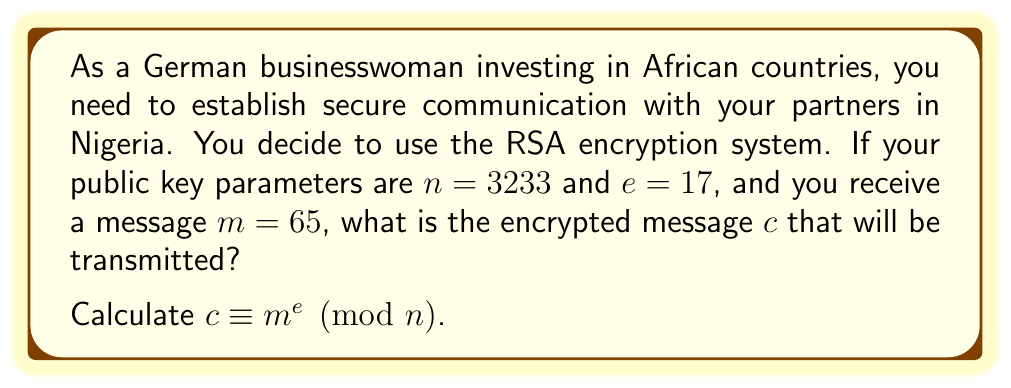Provide a solution to this math problem. To calculate the modular exponentiation $c \equiv m^e \pmod{n}$, we need to compute $65^{17} \pmod{3233}$. This can be done efficiently using the square-and-multiply algorithm:

1) Convert the exponent (17) to binary: $17_{10} = 10001_2$

2) Initialize: $result = 1$, $base = 65$

3) For each bit in the binary exponent (from left to right):
   a) Square the result: $result = result^2 \pmod{3233}$
   b) If the bit is 1, multiply by the base: $result = result \times base \pmod{3233}$

Step-by-step calculation:

1) $result = 1^2 \times 65 \equiv 65 \pmod{3233}$
2) $result = 65^2 \equiv 4225 \equiv 992 \pmod{3233}$
3) $result = 992^2 \equiv 984064 \equiv 2177 \pmod{3233}$
4) $result = 2177^2 \equiv 4739329 \equiv 2690 \pmod{3233}$
5) $result = 2690^2 \times 65 \equiv 7236100 \times 65 \equiv 2108 \times 65 \equiv 2366 \pmod{3233}$

Therefore, the encrypted message $c$ is 2366.
Answer: $c = 2366$ 